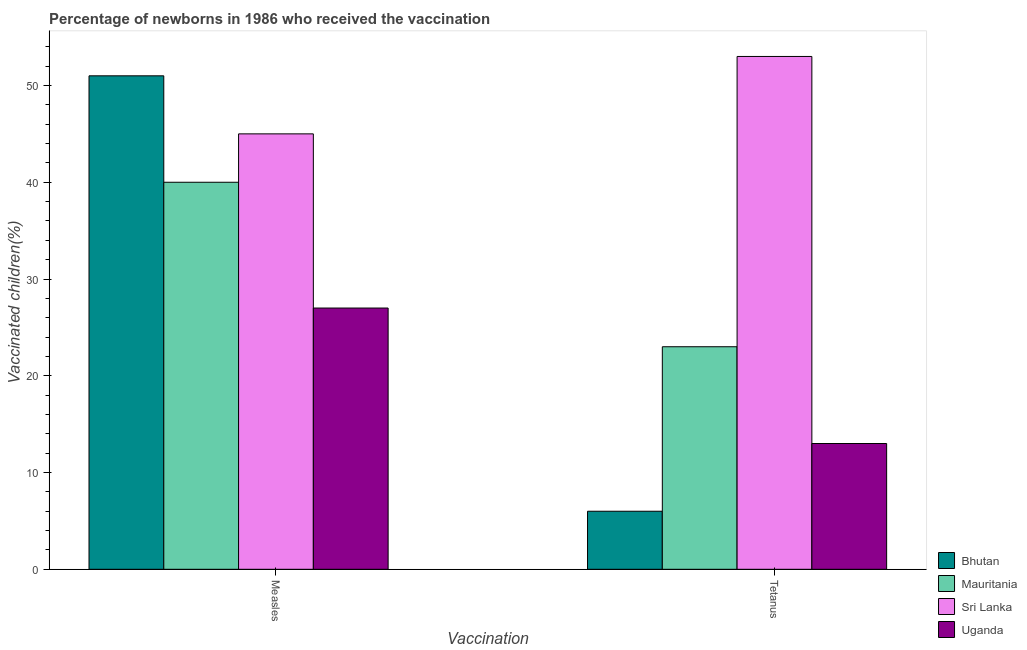How many different coloured bars are there?
Your answer should be very brief. 4. Are the number of bars per tick equal to the number of legend labels?
Offer a very short reply. Yes. How many bars are there on the 1st tick from the left?
Ensure brevity in your answer.  4. How many bars are there on the 2nd tick from the right?
Make the answer very short. 4. What is the label of the 1st group of bars from the left?
Your answer should be compact. Measles. What is the percentage of newborns who received vaccination for measles in Mauritania?
Make the answer very short. 40. Across all countries, what is the maximum percentage of newborns who received vaccination for tetanus?
Offer a terse response. 53. Across all countries, what is the minimum percentage of newborns who received vaccination for tetanus?
Your answer should be compact. 6. In which country was the percentage of newborns who received vaccination for measles maximum?
Offer a very short reply. Bhutan. In which country was the percentage of newborns who received vaccination for measles minimum?
Ensure brevity in your answer.  Uganda. What is the total percentage of newborns who received vaccination for tetanus in the graph?
Keep it short and to the point. 95. What is the difference between the percentage of newborns who received vaccination for measles in Mauritania and that in Uganda?
Offer a terse response. 13. What is the difference between the percentage of newborns who received vaccination for measles in Mauritania and the percentage of newborns who received vaccination for tetanus in Sri Lanka?
Provide a short and direct response. -13. What is the average percentage of newborns who received vaccination for tetanus per country?
Offer a terse response. 23.75. What is the difference between the percentage of newborns who received vaccination for tetanus and percentage of newborns who received vaccination for measles in Bhutan?
Offer a terse response. -45. What is the ratio of the percentage of newborns who received vaccination for tetanus in Uganda to that in Bhutan?
Offer a terse response. 2.17. In how many countries, is the percentage of newborns who received vaccination for measles greater than the average percentage of newborns who received vaccination for measles taken over all countries?
Your response must be concise. 2. What does the 2nd bar from the left in Measles represents?
Provide a short and direct response. Mauritania. What does the 2nd bar from the right in Measles represents?
Offer a very short reply. Sri Lanka. How many bars are there?
Your answer should be compact. 8. Where does the legend appear in the graph?
Give a very brief answer. Bottom right. How are the legend labels stacked?
Give a very brief answer. Vertical. What is the title of the graph?
Keep it short and to the point. Percentage of newborns in 1986 who received the vaccination. Does "Sudan" appear as one of the legend labels in the graph?
Your answer should be compact. No. What is the label or title of the X-axis?
Your answer should be compact. Vaccination. What is the label or title of the Y-axis?
Give a very brief answer. Vaccinated children(%)
. What is the Vaccinated children(%)
 of Uganda in Measles?
Keep it short and to the point. 27. What is the Vaccinated children(%)
 in Bhutan in Tetanus?
Your answer should be very brief. 6. What is the Vaccinated children(%)
 of Uganda in Tetanus?
Provide a succinct answer. 13. Across all Vaccination, what is the maximum Vaccinated children(%)
 in Bhutan?
Provide a short and direct response. 51. Across all Vaccination, what is the maximum Vaccinated children(%)
 in Sri Lanka?
Provide a short and direct response. 53. Across all Vaccination, what is the minimum Vaccinated children(%)
 of Bhutan?
Provide a short and direct response. 6. Across all Vaccination, what is the minimum Vaccinated children(%)
 in Sri Lanka?
Keep it short and to the point. 45. Across all Vaccination, what is the minimum Vaccinated children(%)
 in Uganda?
Your answer should be compact. 13. What is the total Vaccinated children(%)
 in Bhutan in the graph?
Ensure brevity in your answer.  57. What is the total Vaccinated children(%)
 in Uganda in the graph?
Offer a very short reply. 40. What is the difference between the Vaccinated children(%)
 of Bhutan in Measles and that in Tetanus?
Your response must be concise. 45. What is the difference between the Vaccinated children(%)
 of Mauritania in Measles and that in Tetanus?
Offer a terse response. 17. What is the difference between the Vaccinated children(%)
 of Bhutan in Measles and the Vaccinated children(%)
 of Mauritania in Tetanus?
Offer a terse response. 28. What is the difference between the Vaccinated children(%)
 in Bhutan in Measles and the Vaccinated children(%)
 in Sri Lanka in Tetanus?
Offer a very short reply. -2. What is the difference between the Vaccinated children(%)
 of Sri Lanka in Measles and the Vaccinated children(%)
 of Uganda in Tetanus?
Provide a short and direct response. 32. What is the average Vaccinated children(%)
 of Mauritania per Vaccination?
Your response must be concise. 31.5. What is the average Vaccinated children(%)
 of Sri Lanka per Vaccination?
Provide a short and direct response. 49. What is the difference between the Vaccinated children(%)
 in Bhutan and Vaccinated children(%)
 in Mauritania in Measles?
Give a very brief answer. 11. What is the difference between the Vaccinated children(%)
 in Bhutan and Vaccinated children(%)
 in Uganda in Measles?
Offer a very short reply. 24. What is the difference between the Vaccinated children(%)
 in Sri Lanka and Vaccinated children(%)
 in Uganda in Measles?
Make the answer very short. 18. What is the difference between the Vaccinated children(%)
 in Bhutan and Vaccinated children(%)
 in Sri Lanka in Tetanus?
Your answer should be very brief. -47. What is the difference between the Vaccinated children(%)
 in Mauritania and Vaccinated children(%)
 in Sri Lanka in Tetanus?
Keep it short and to the point. -30. What is the ratio of the Vaccinated children(%)
 of Bhutan in Measles to that in Tetanus?
Provide a short and direct response. 8.5. What is the ratio of the Vaccinated children(%)
 in Mauritania in Measles to that in Tetanus?
Offer a terse response. 1.74. What is the ratio of the Vaccinated children(%)
 of Sri Lanka in Measles to that in Tetanus?
Provide a succinct answer. 0.85. What is the ratio of the Vaccinated children(%)
 in Uganda in Measles to that in Tetanus?
Ensure brevity in your answer.  2.08. What is the difference between the highest and the second highest Vaccinated children(%)
 in Bhutan?
Provide a succinct answer. 45. What is the difference between the highest and the second highest Vaccinated children(%)
 of Sri Lanka?
Make the answer very short. 8. What is the difference between the highest and the second highest Vaccinated children(%)
 in Uganda?
Provide a short and direct response. 14. What is the difference between the highest and the lowest Vaccinated children(%)
 of Bhutan?
Your answer should be compact. 45. What is the difference between the highest and the lowest Vaccinated children(%)
 in Mauritania?
Your answer should be compact. 17. What is the difference between the highest and the lowest Vaccinated children(%)
 in Uganda?
Provide a short and direct response. 14. 